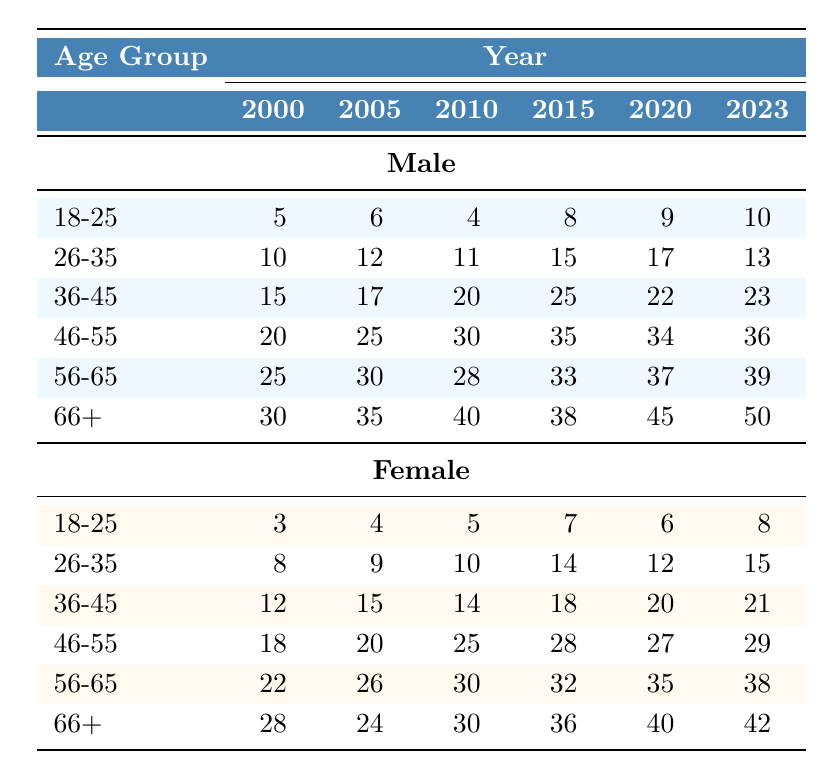What is the number of male recipients aged 46-55 in 2010? In the table, locate the row for the age group 46-55 under the column for the year 2010 in the male category. The value in that cell is 30.
Answer: 30 What is the total number of female recipients aged 66+ across all years? To find the total, add the values of female recipients aged 66+ from each year: 28 (2000) + 24 (2005) + 30 (2010) + 36 (2015) + 40 (2020) + 42 (2023) = 200.
Answer: 200 In which year did male recipients aged 18-25 receive the highest number of awards? Review the values in the 18-25 row for male recipients across all years: 5 (2000), 6 (2005), 4 (2010), 8 (2015), 9 (2020), 10 (2023). The highest number is 10, which occurred in 2023.
Answer: 2023 Are there more male or female recipients aged 36-45 in the year 2023? Check the number of male and female recipients aged 36-45 in 2023. Male: 23, Female: 21. Since 23 is greater than 21, there are more male recipients.
Answer: Yes, more male recipients What is the percentage increase in male recipients aged 56-65 from 2000 to 2023? First, find the values for male recipients aged 56-65 in both years: 25 (2000) and 39 (2023). The increase is 39 - 25 = 14. To find the percentage increase, use the formula (increase/original) * 100: (14/25) * 100 = 56%.
Answer: 56% How many male recipients aged 66+ were honored in 2015 compared to 2020? Check the number of male recipients aged 66+ for both years: 38 (2015) and 45 (2020). The difference is 45 - 38 = 7 more recipients in 2020.
Answer: 7 more recipients in 2020 In the year 2010, what was the total number of recipients (male and female) in the 46-55 age group? Locate the 46-55 row under both male and female categories for the year 2010. The values are 30 (male) and 25 (female). Adding these gives 30 + 25 = 55.
Answer: 55 What can be said about female recipients aged 26-35 over the years? Examining the values for female recipients aged 26-35 over the years shows generally increasing trends. The values are: 8 (2000), 9 (2005), 10 (2010), 14 (2015), 12 (2020), 15 (2023). Thus, the number generally increased.
Answer: Generally increasing trend 